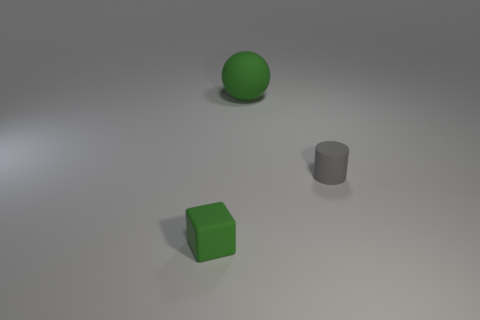Add 2 red shiny blocks. How many objects exist? 5 Subtract all cylinders. How many objects are left? 2 Subtract 1 cubes. How many cubes are left? 0 Subtract all yellow balls. Subtract all blue cubes. How many balls are left? 1 Subtract all cyan spheres. How many brown blocks are left? 0 Subtract all spheres. Subtract all small cubes. How many objects are left? 1 Add 1 green rubber objects. How many green rubber objects are left? 3 Add 3 big blue matte spheres. How many big blue matte spheres exist? 3 Subtract 0 purple cylinders. How many objects are left? 3 